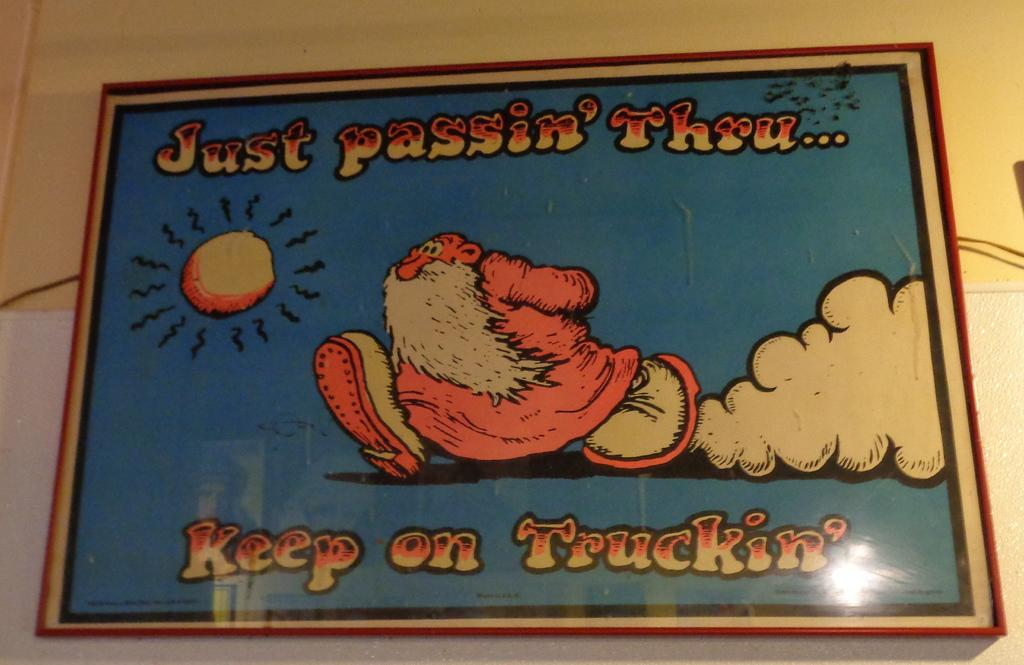<image>
Provide a brief description of the given image. a photo with the line keep on truckin on it 